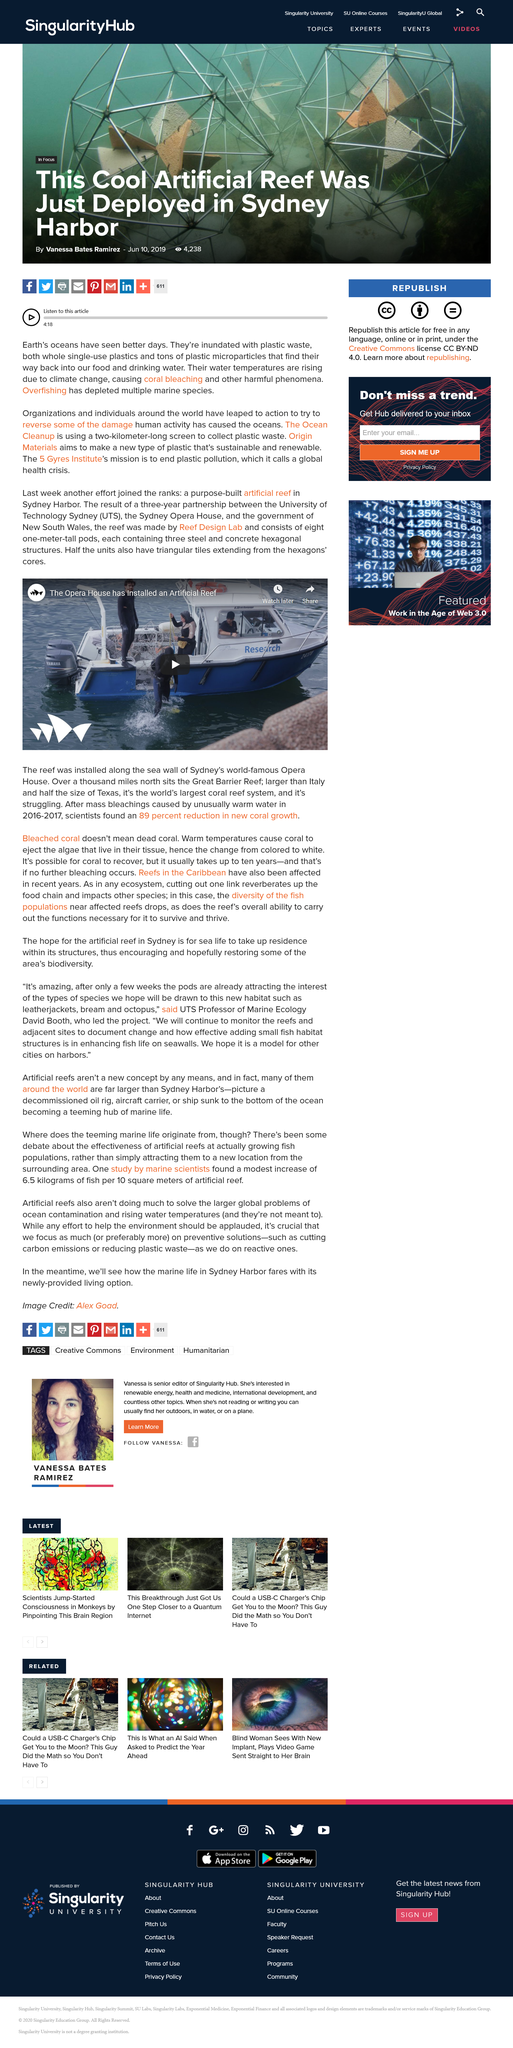List a handful of essential elements in this visual. The Great Barrier Reef is larger than Italy. It can take up to ten years for coral to fully recover after being bleached. The bleached coral along the sea wall of Sydney's opera house is not necessarily dead coral. It can recover and re-grow, despite being affected by environmental stressors. 